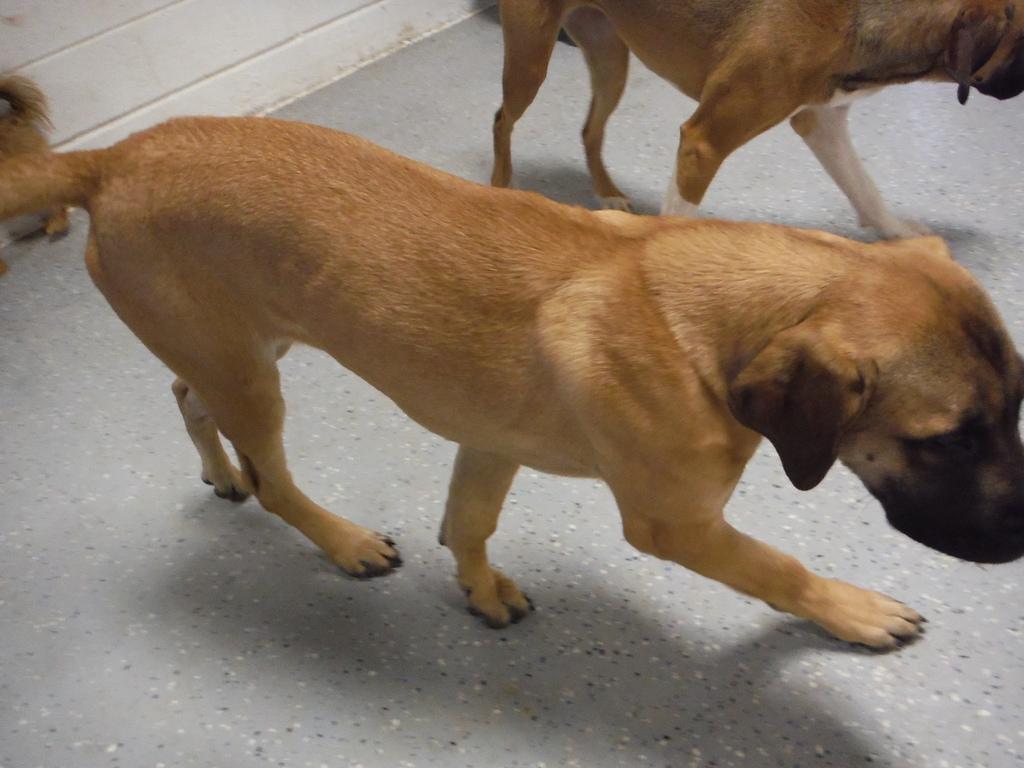Could you give a brief overview of what you see in this image? In the middle it is a dog which is in brown color. At the top there is another dog. 